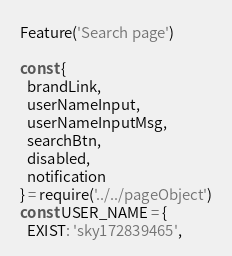<code> <loc_0><loc_0><loc_500><loc_500><_JavaScript_>Feature('Search page')

const {
  brandLink,
  userNameInput,
  userNameInputMsg,
  searchBtn,
  disabled,
  notification
} = require('../../pageObject')
const USER_NAME = {
  EXIST: 'sky172839465',</code> 